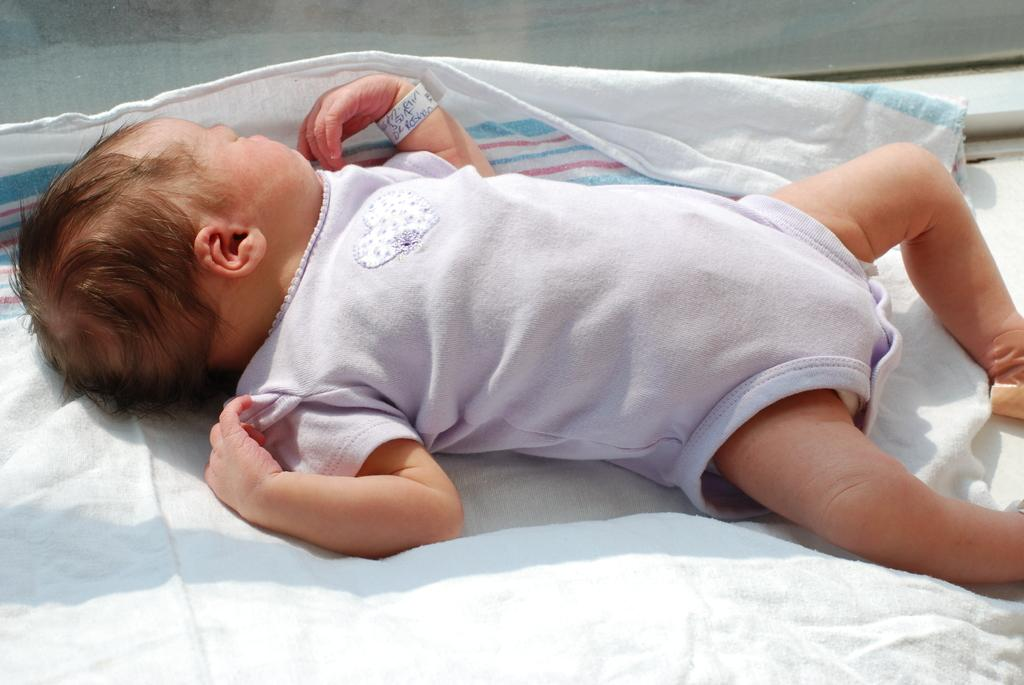What is the main subject of the picture? The main subject of the picture is a baby. What is the baby doing in the picture? The baby is sleeping in the picture. What is the baby lying on? The baby is on a white color cloth. What type of advice can be heard coming from the baby in the picture? There is no indication in the baby is giving advice in the image, as the baby is sleeping. 